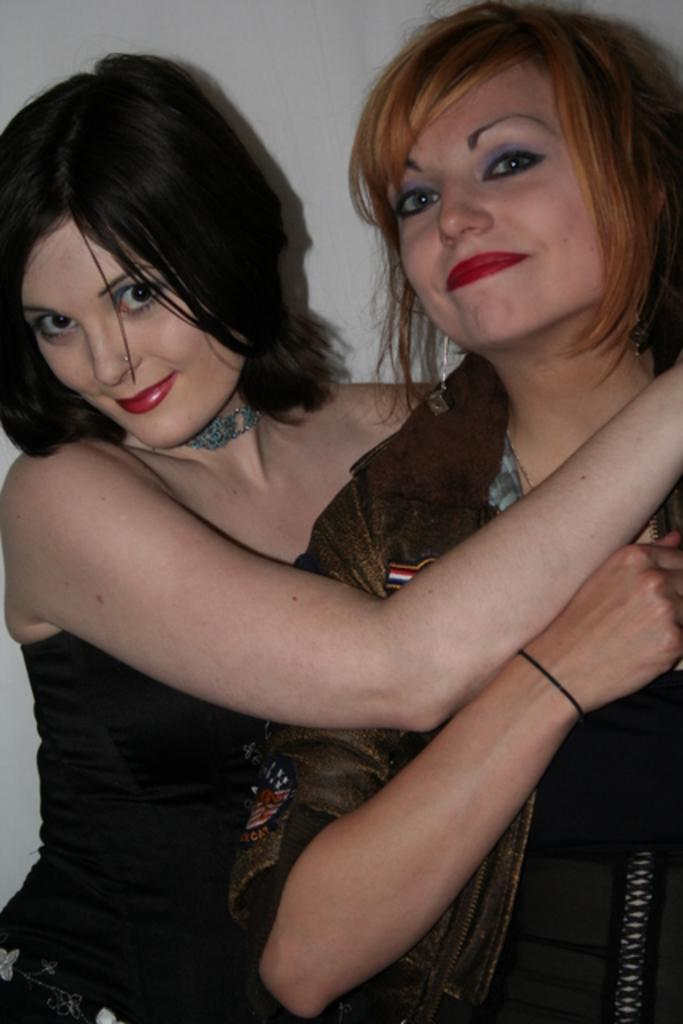How many women are present in the image? There are two women standing in the image. Can you describe the background of the image? There is a wall in the background of the image. What type of transport is being used by the women in the image? There is no visible transport in the image; the women are standing. What type of punishment is being administered to the women in the image? There is no punishment being administered to the women in the image; they are simply standing. 